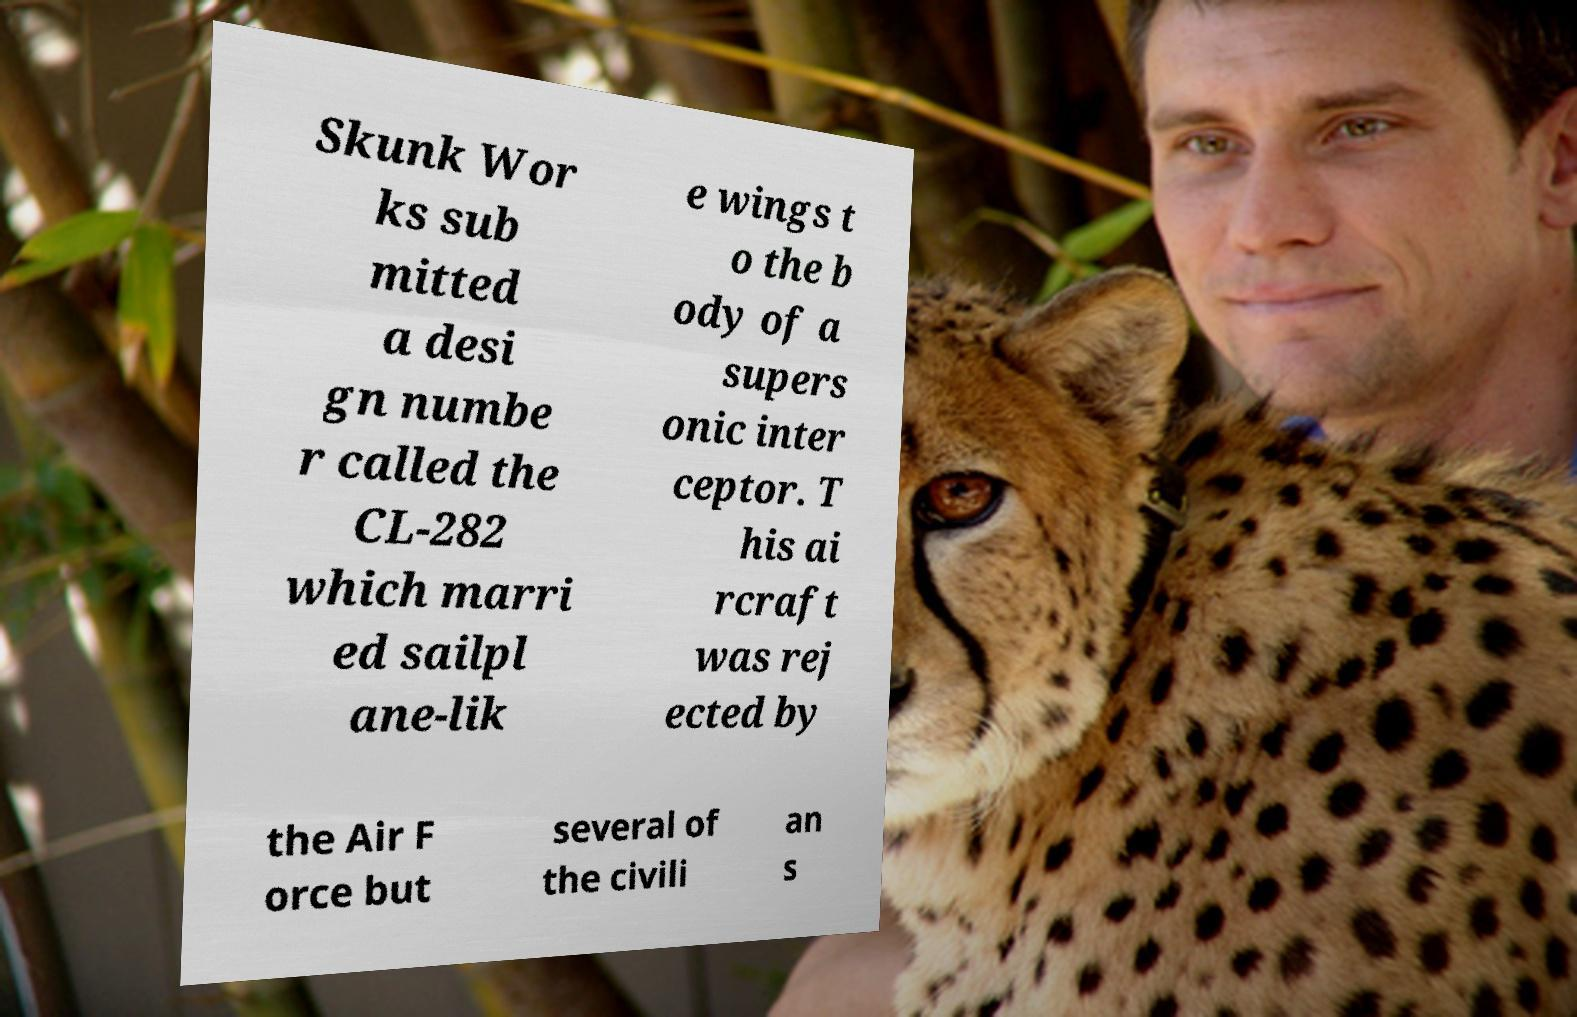I need the written content from this picture converted into text. Can you do that? Skunk Wor ks sub mitted a desi gn numbe r called the CL-282 which marri ed sailpl ane-lik e wings t o the b ody of a supers onic inter ceptor. T his ai rcraft was rej ected by the Air F orce but several of the civili an s 